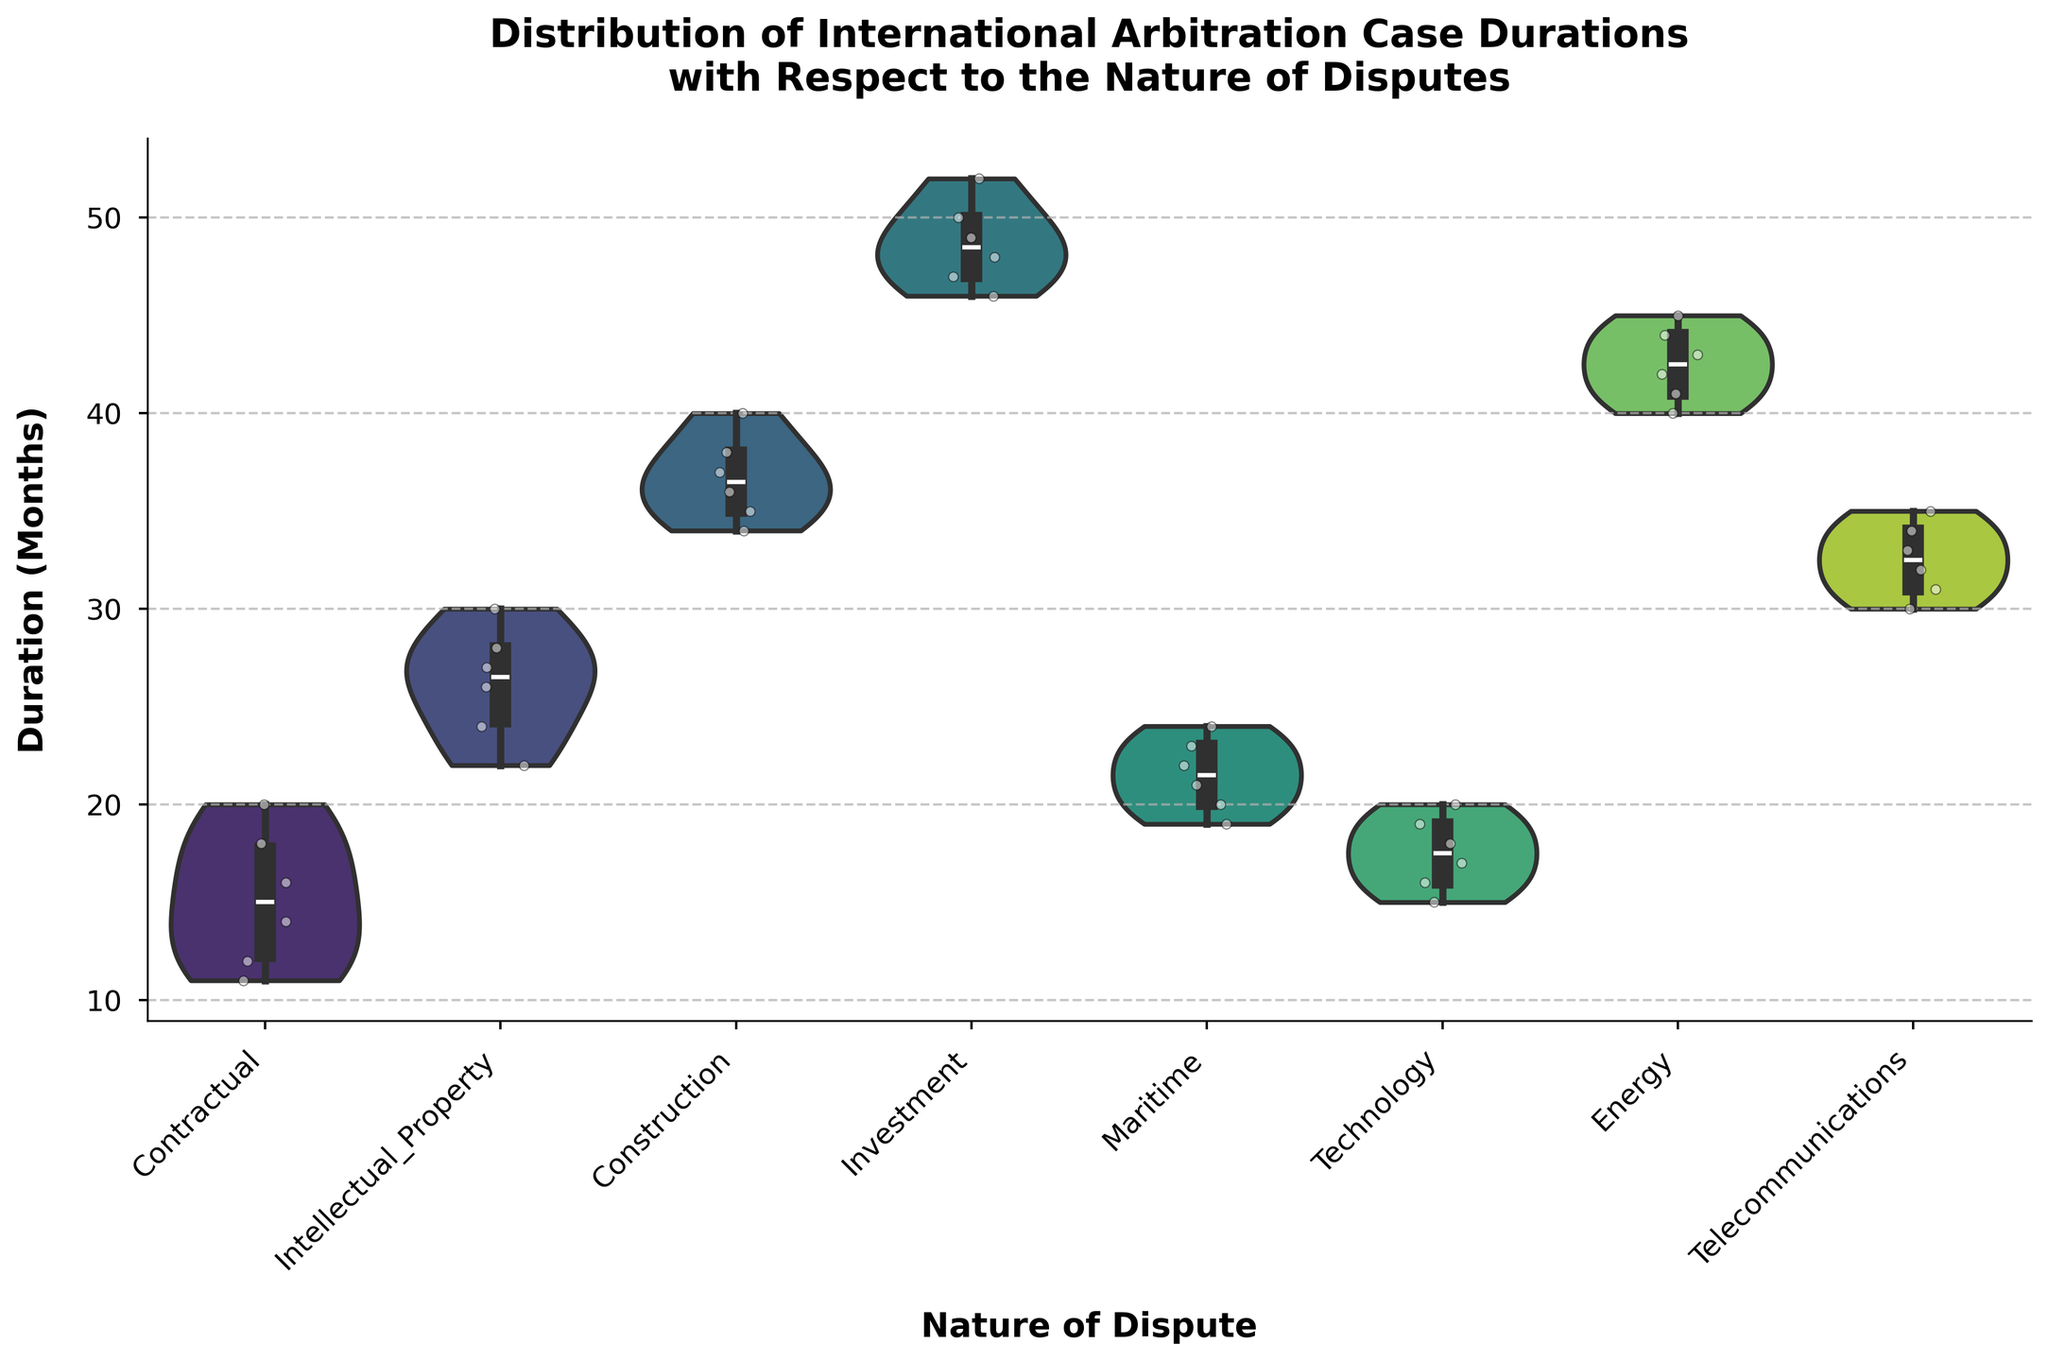What is the title of the figure? The title is located at the top of the figure, and it summarizes what the figure is about.
Answer: Distribution of International Arbitration Case Durations with Respect to the Nature of Disputes What is the median duration for Contractual disputes? To find the median, look at the box inside the violin plot for Contractual disputes; the line inside the box represents the median.
Answer: 15 months Which type of dispute has the longest median duration? Compare the median lines in the box plots for all types of disputes to see which one is the highest.
Answer: Investment How does the range of durations for Intellectual Property disputes compare to that of Maritime disputes? Look at the spread of the violin plots for both Intellectual Property and Maritime disputes to compare their ranges. Intellectual Property ranges from 22 to 30 months, whereas Maritime ranges from 19 to 24 months.
Answer: Intellectual Property disputes have a wider range What is the interquartile range for Construction disputes? The interquartile range (IQR) is the difference between the third quartile (Q3) and the first quartile (Q1) in the box plot overlay. For Construction disputes, Q3 is approximately 38 months, and Q1 is around 35 months. The IQR is 38 - 35.
Answer: 3 months Which type of dispute has the most concentration of case durations around the median? The most concentrated distribution will have the narrowest waist in the violin plot. By observing the violin plots, Maritime disputes have a very narrow waist around the median.
Answer: Maritime Which type of dispute shows the highest variability in case durations? Variability is indicated by the width of the violin plot. Investment disputes have the widest plot, indicating the highest variability.
Answer: Investment Do technology disputes generally take longer than contractual disputes? Compare the median lines and the general spread of the durations for both Technology and Contractual disputes. The median for Technology is around 17 months whereas for Contractual it is around 15 months.
Answer: Yes What is the approximate mean duration for Telecommunications disputes considering the spread and median? While exact mean is not directly visible, looking at the distribution, median is around 32.5 months, and the spread from 30 to 35 months seems quite symmetrical.
Answer: 32-33 months Which dispute category has an outlier, and what can you infer about the duration of cases in this category? Look for individual white dots outside the bulk of the distribution. No clear outliers are visible, implying there's no extreme variation within any dispute category here.
Answer: None 